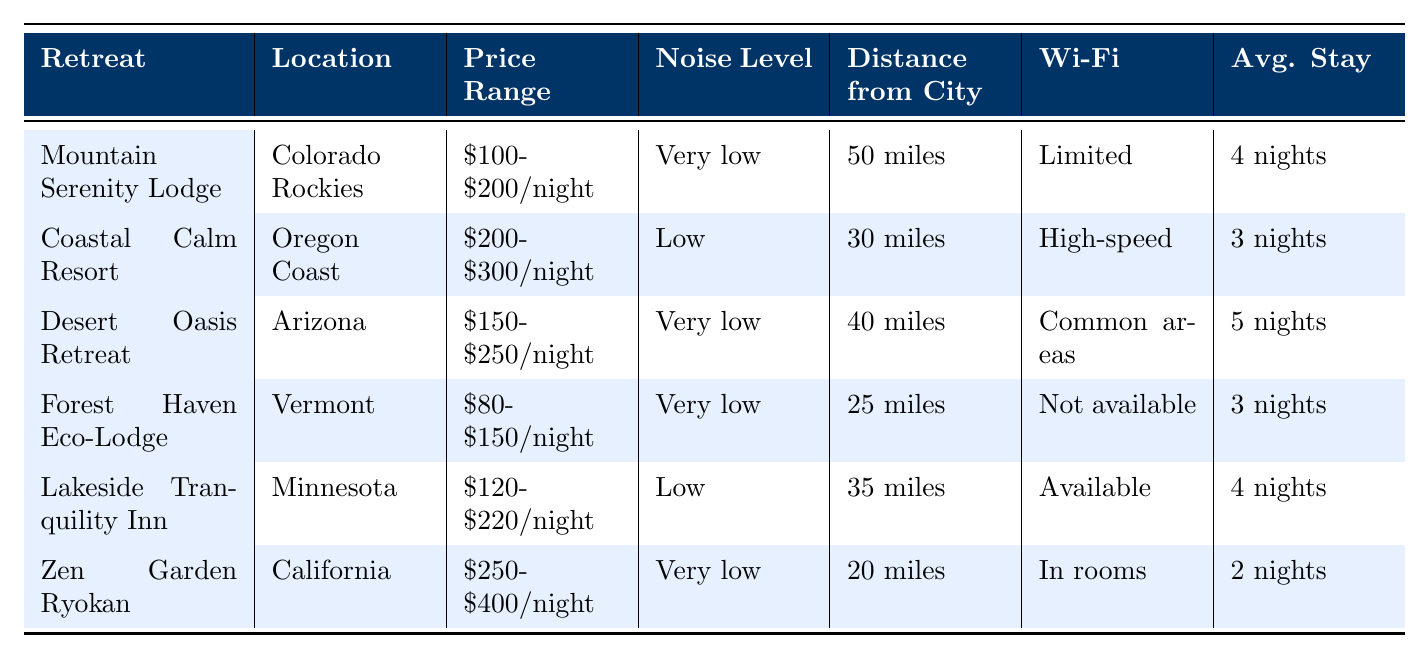What is the price range of the Forest Haven Eco-Lodge? According to the table, the price range for the Forest Haven Eco-Lodge is listed as $80-$150/night.
Answer: $80-$150/night Which retreat has the highest noise level? The Coastal Calm Resort has the highest noise level recorded as "Low". Other retreats show "Very low" noise levels.
Answer: Coastal Calm Resort How many retreats offer meditation spaces? All the retreats listed in the table indicate that they have meditation spaces available. This can be seen directly in the "meditation spaces" column where all entries say "Yes".
Answer: 6 Which retreat is located the furthest from the city? To determine which retreat is furthest, we can compare the distances listed. The Mountain Serenity Lodge is 50 miles away from the city, which is the highest distance compared to the others.
Answer: Mountain Serenity Lodge What is the average stay duration for Zen Garden Ryokan? The table shows that the average stay duration for Zen Garden Ryokan is 2 nights, as stated in the "Avg. Stay" column for this retreat.
Answer: 2 nights Which retreat has a higher price range, Coastal Calm Resort or Desert Oasis Retreat? The Coastal Calm Resort has a price range of $200-$300/night, while the Desert Oasis Retreat ranges from $150-$250/night. Since $200-$300 is higher than $150-$250, Coastal Calm Resort has the higher price range.
Answer: Coastal Calm Resort Is the Wi-Fi availability at Forest Haven Eco-Lodge noted as limited or not available? The table indicates that Wi-Fi is "Not available" for the Forest Haven Eco-Lodge, which is a specific fact listed in the Wi-Fi column.
Answer: Not available What is the total price range difference between the most expensive retreat and the least expensive one? Here, the most expensive retreat is Zen Garden Ryokan ($250-$400), and the least expensive is Forest Haven Eco-Lodge ($80-$150). The total price range is calculated by taking the maximum price of the most expensive one ($400) and subtracting the minimum price of the least expensive one ($80), resulting in a difference of $320.
Answer: $320 Which retreat offers the shortest average stay? Looking through the table, the Zen Garden Ryokan has the shortest average stay duration, which is 2 nights, compared to all the other retreats.
Answer: Zen Garden Ryokan Does Lakeside Tranquility Inn provide meal options that include breakfast? Yes, the table specifies that Lakeside Tranquility Inn offers meal options with "Breakfast included," confirming this fact.
Answer: Yes 